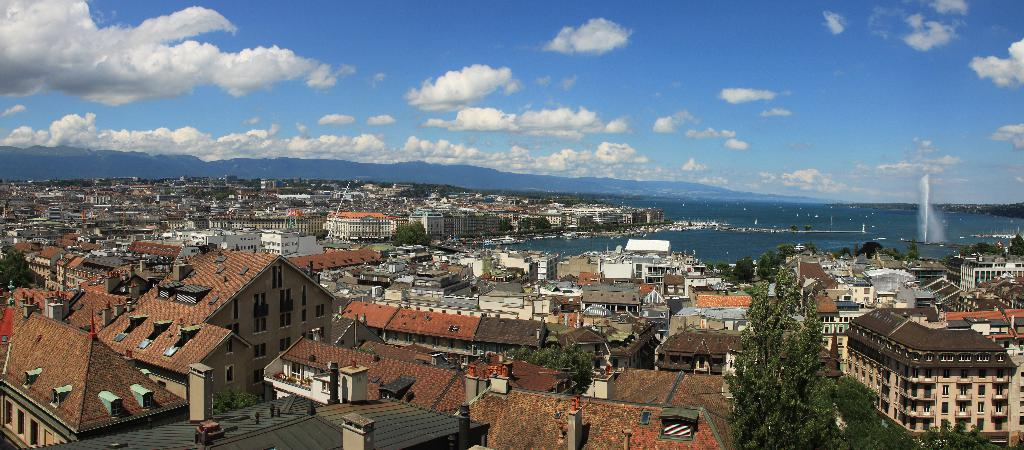What type of view is shown in the image? The image is an aerial view of a city. What can be seen within the city? There are buildings throughout the city. What is visible in the background of the image? There is an ocean in the background. What natural feature is present on the right side of the image? There are hills on the right side of the image. What part of the sky is visible in the image? The sky is visible in the image. What atmospheric feature can be seen in the sky? Clouds are present in the sky. How does the beggar feel about the design of the city in the image? There is no beggar present in the image, so it is impossible to determine their feelings about the design of the city. 